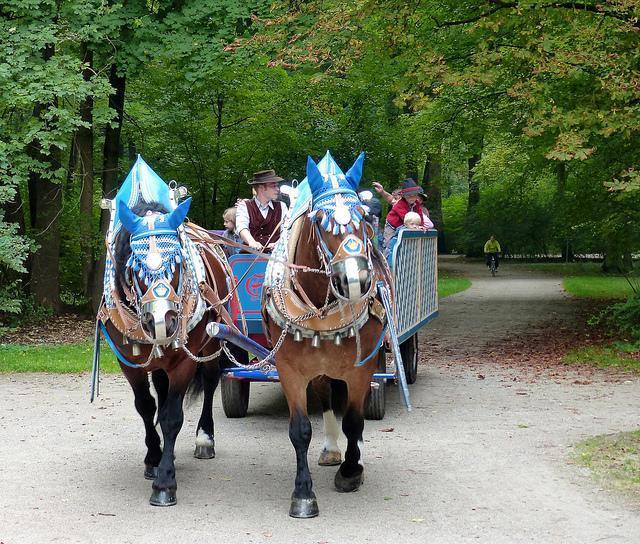How many people are there?
Give a very brief answer. 4. How many horses are in the picture?
Give a very brief answer. 2. How many yellow taxi cars are in this image?
Give a very brief answer. 0. 